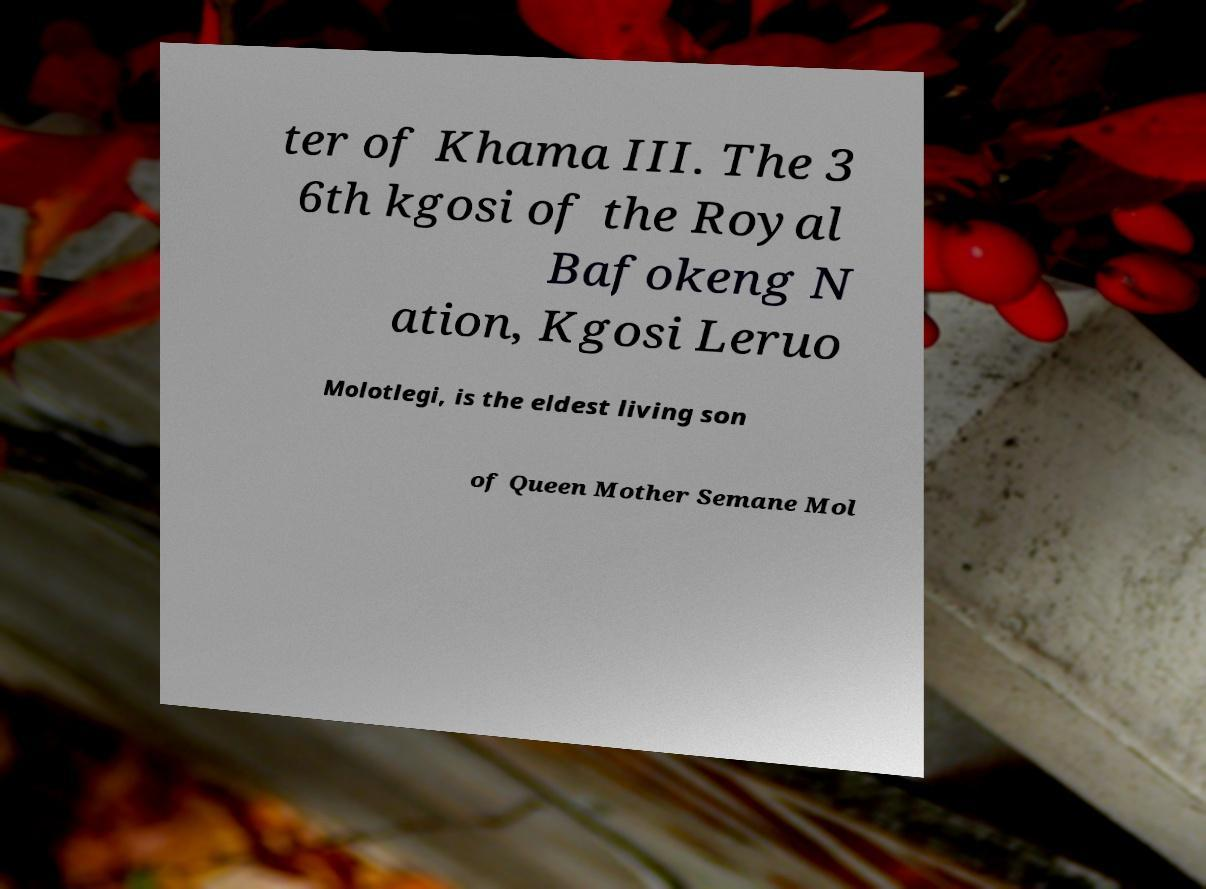Can you accurately transcribe the text from the provided image for me? ter of Khama III. The 3 6th kgosi of the Royal Bafokeng N ation, Kgosi Leruo Molotlegi, is the eldest living son of Queen Mother Semane Mol 